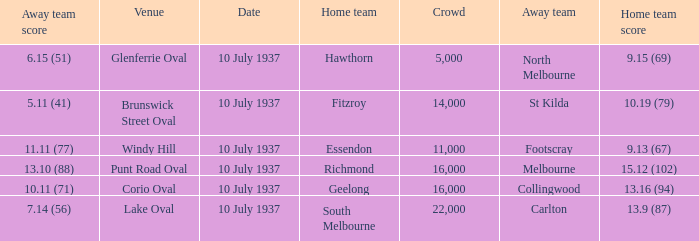What was the lowest Crowd during the Away Team Score of 10.11 (71)? 16000.0. 